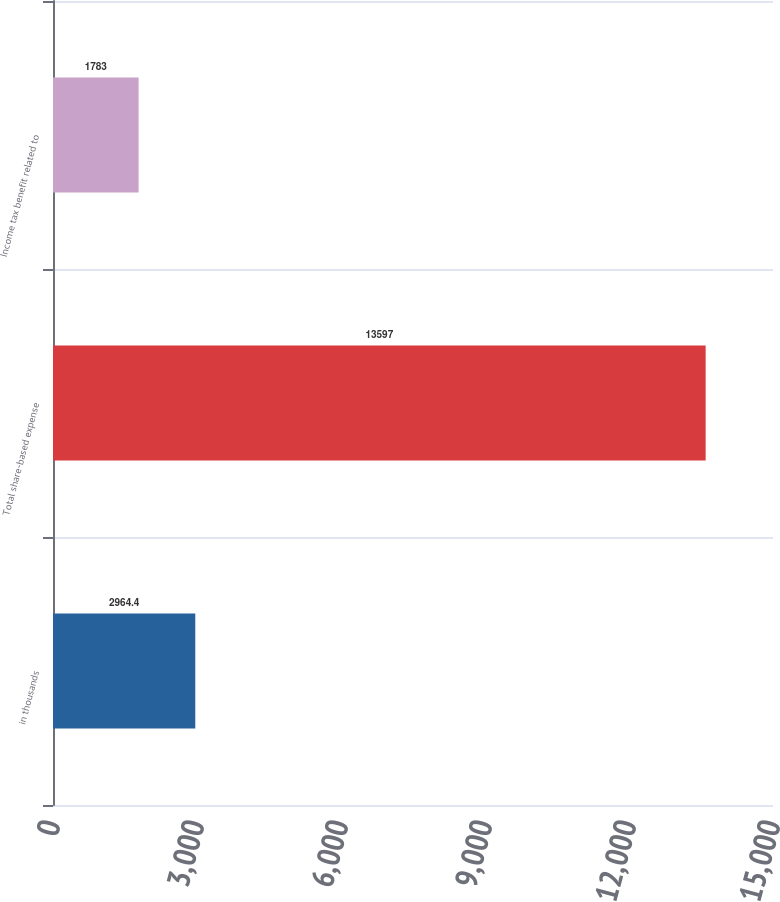Convert chart. <chart><loc_0><loc_0><loc_500><loc_500><bar_chart><fcel>in thousands<fcel>Total share-based expense<fcel>Income tax benefit related to<nl><fcel>2964.4<fcel>13597<fcel>1783<nl></chart> 